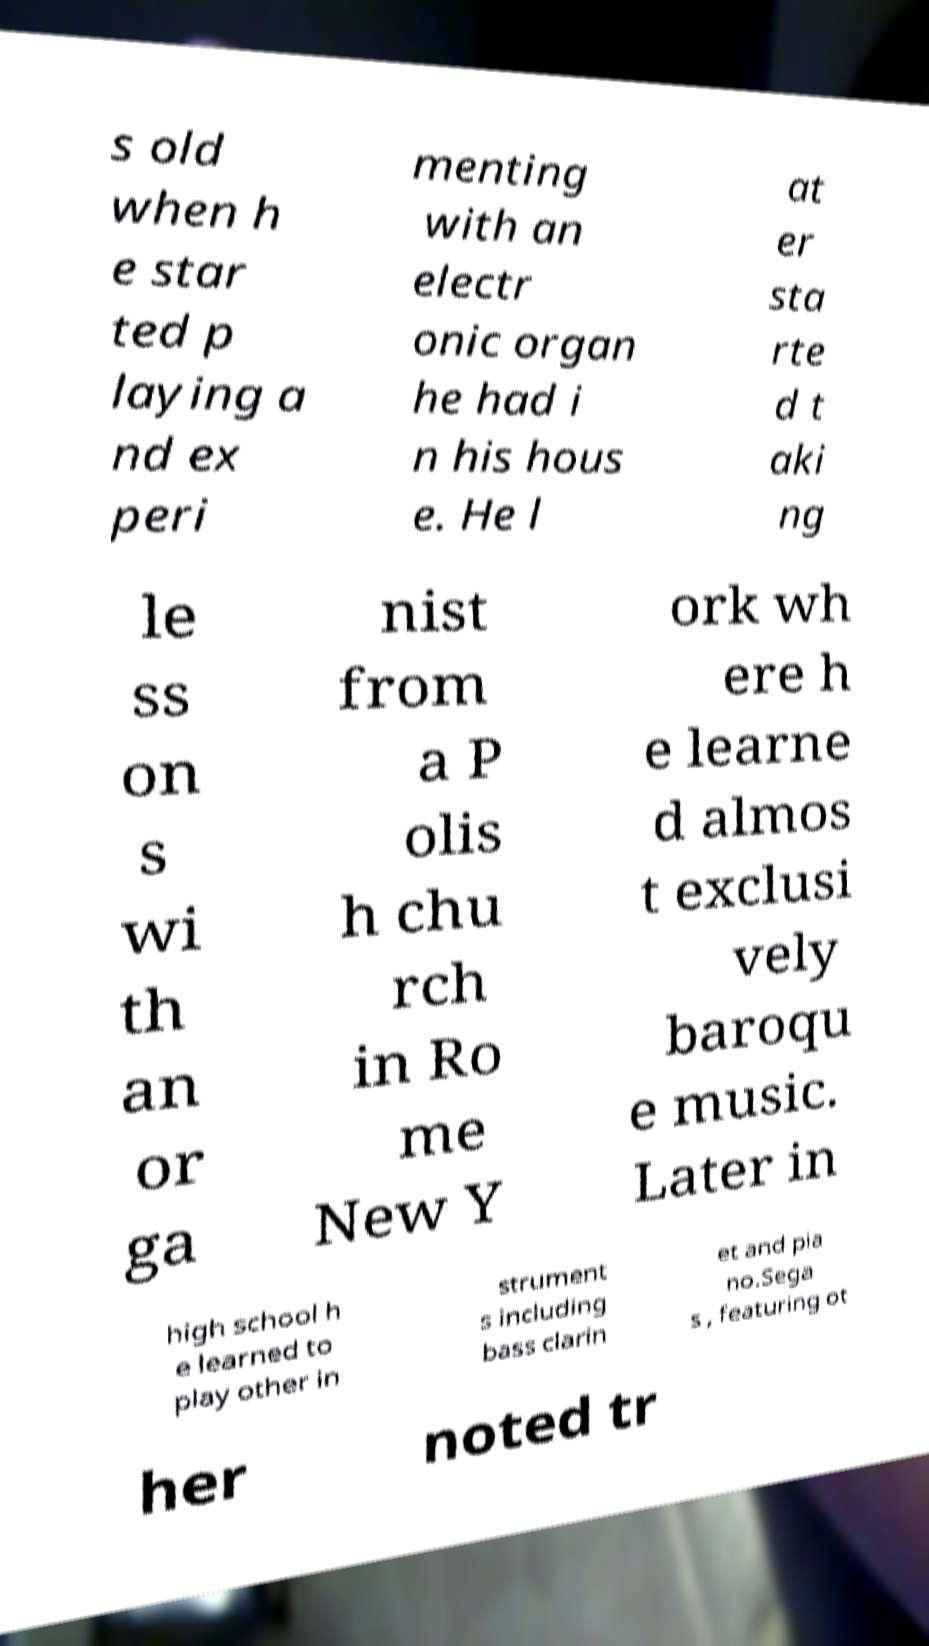Could you extract and type out the text from this image? s old when h e star ted p laying a nd ex peri menting with an electr onic organ he had i n his hous e. He l at er sta rte d t aki ng le ss on s wi th an or ga nist from a P olis h chu rch in Ro me New Y ork wh ere h e learne d almos t exclusi vely baroqu e music. Later in high school h e learned to play other in strument s including bass clarin et and pia no.Sega s , featuring ot her noted tr 